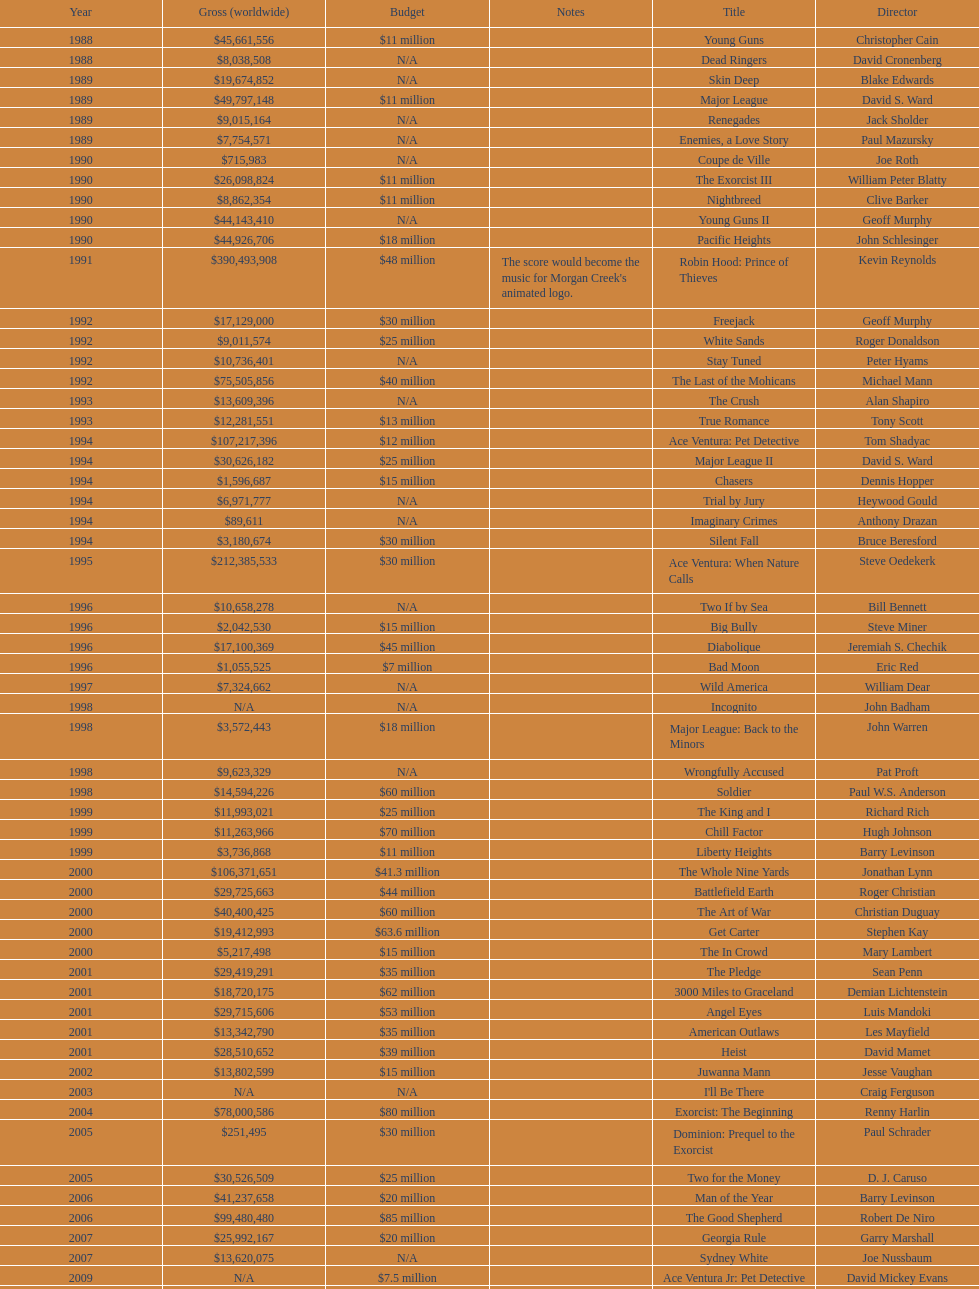What is the number of films directed by david s. ward? 2. Could you help me parse every detail presented in this table? {'header': ['Year', 'Gross (worldwide)', 'Budget', 'Notes', 'Title', 'Director'], 'rows': [['1988', '$45,661,556', '$11 million', '', 'Young Guns', 'Christopher Cain'], ['1988', '$8,038,508', 'N/A', '', 'Dead Ringers', 'David Cronenberg'], ['1989', '$19,674,852', 'N/A', '', 'Skin Deep', 'Blake Edwards'], ['1989', '$49,797,148', '$11 million', '', 'Major League', 'David S. Ward'], ['1989', '$9,015,164', 'N/A', '', 'Renegades', 'Jack Sholder'], ['1989', '$7,754,571', 'N/A', '', 'Enemies, a Love Story', 'Paul Mazursky'], ['1990', '$715,983', 'N/A', '', 'Coupe de Ville', 'Joe Roth'], ['1990', '$26,098,824', '$11 million', '', 'The Exorcist III', 'William Peter Blatty'], ['1990', '$8,862,354', '$11 million', '', 'Nightbreed', 'Clive Barker'], ['1990', '$44,143,410', 'N/A', '', 'Young Guns II', 'Geoff Murphy'], ['1990', '$44,926,706', '$18 million', '', 'Pacific Heights', 'John Schlesinger'], ['1991', '$390,493,908', '$48 million', "The score would become the music for Morgan Creek's animated logo.", 'Robin Hood: Prince of Thieves', 'Kevin Reynolds'], ['1992', '$17,129,000', '$30 million', '', 'Freejack', 'Geoff Murphy'], ['1992', '$9,011,574', '$25 million', '', 'White Sands', 'Roger Donaldson'], ['1992', '$10,736,401', 'N/A', '', 'Stay Tuned', 'Peter Hyams'], ['1992', '$75,505,856', '$40 million', '', 'The Last of the Mohicans', 'Michael Mann'], ['1993', '$13,609,396', 'N/A', '', 'The Crush', 'Alan Shapiro'], ['1993', '$12,281,551', '$13 million', '', 'True Romance', 'Tony Scott'], ['1994', '$107,217,396', '$12 million', '', 'Ace Ventura: Pet Detective', 'Tom Shadyac'], ['1994', '$30,626,182', '$25 million', '', 'Major League II', 'David S. Ward'], ['1994', '$1,596,687', '$15 million', '', 'Chasers', 'Dennis Hopper'], ['1994', '$6,971,777', 'N/A', '', 'Trial by Jury', 'Heywood Gould'], ['1994', '$89,611', 'N/A', '', 'Imaginary Crimes', 'Anthony Drazan'], ['1994', '$3,180,674', '$30 million', '', 'Silent Fall', 'Bruce Beresford'], ['1995', '$212,385,533', '$30 million', '', 'Ace Ventura: When Nature Calls', 'Steve Oedekerk'], ['1996', '$10,658,278', 'N/A', '', 'Two If by Sea', 'Bill Bennett'], ['1996', '$2,042,530', '$15 million', '', 'Big Bully', 'Steve Miner'], ['1996', '$17,100,369', '$45 million', '', 'Diabolique', 'Jeremiah S. Chechik'], ['1996', '$1,055,525', '$7 million', '', 'Bad Moon', 'Eric Red'], ['1997', '$7,324,662', 'N/A', '', 'Wild America', 'William Dear'], ['1998', 'N/A', 'N/A', '', 'Incognito', 'John Badham'], ['1998', '$3,572,443', '$18 million', '', 'Major League: Back to the Minors', 'John Warren'], ['1998', '$9,623,329', 'N/A', '', 'Wrongfully Accused', 'Pat Proft'], ['1998', '$14,594,226', '$60 million', '', 'Soldier', 'Paul W.S. Anderson'], ['1999', '$11,993,021', '$25 million', '', 'The King and I', 'Richard Rich'], ['1999', '$11,263,966', '$70 million', '', 'Chill Factor', 'Hugh Johnson'], ['1999', '$3,736,868', '$11 million', '', 'Liberty Heights', 'Barry Levinson'], ['2000', '$106,371,651', '$41.3 million', '', 'The Whole Nine Yards', 'Jonathan Lynn'], ['2000', '$29,725,663', '$44 million', '', 'Battlefield Earth', 'Roger Christian'], ['2000', '$40,400,425', '$60 million', '', 'The Art of War', 'Christian Duguay'], ['2000', '$19,412,993', '$63.6 million', '', 'Get Carter', 'Stephen Kay'], ['2000', '$5,217,498', '$15 million', '', 'The In Crowd', 'Mary Lambert'], ['2001', '$29,419,291', '$35 million', '', 'The Pledge', 'Sean Penn'], ['2001', '$18,720,175', '$62 million', '', '3000 Miles to Graceland', 'Demian Lichtenstein'], ['2001', '$29,715,606', '$53 million', '', 'Angel Eyes', 'Luis Mandoki'], ['2001', '$13,342,790', '$35 million', '', 'American Outlaws', 'Les Mayfield'], ['2001', '$28,510,652', '$39 million', '', 'Heist', 'David Mamet'], ['2002', '$13,802,599', '$15 million', '', 'Juwanna Mann', 'Jesse Vaughan'], ['2003', 'N/A', 'N/A', '', "I'll Be There", 'Craig Ferguson'], ['2004', '$78,000,586', '$80 million', '', 'Exorcist: The Beginning', 'Renny Harlin'], ['2005', '$251,495', '$30 million', '', 'Dominion: Prequel to the Exorcist', 'Paul Schrader'], ['2005', '$30,526,509', '$25 million', '', 'Two for the Money', 'D. J. Caruso'], ['2006', '$41,237,658', '$20 million', '', 'Man of the Year', 'Barry Levinson'], ['2006', '$99,480,480', '$85 million', '', 'The Good Shepherd', 'Robert De Niro'], ['2007', '$25,992,167', '$20 million', '', 'Georgia Rule', 'Garry Marshall'], ['2007', '$13,620,075', 'N/A', '', 'Sydney White', 'Joe Nussbaum'], ['2009', 'N/A', '$7.5 million', '', 'Ace Ventura Jr: Pet Detective', 'David Mickey Evans'], ['2011', '$38,502,340', '$50 million', '', 'Dream House', 'Jim Sheridan'], ['2011', '$27,428,670', '$38 million', '', 'The Thing', 'Matthijs van Heijningen Jr.'], ['2014', '', '$45 million', '', 'Tupac', 'Antoine Fuqua']]} 